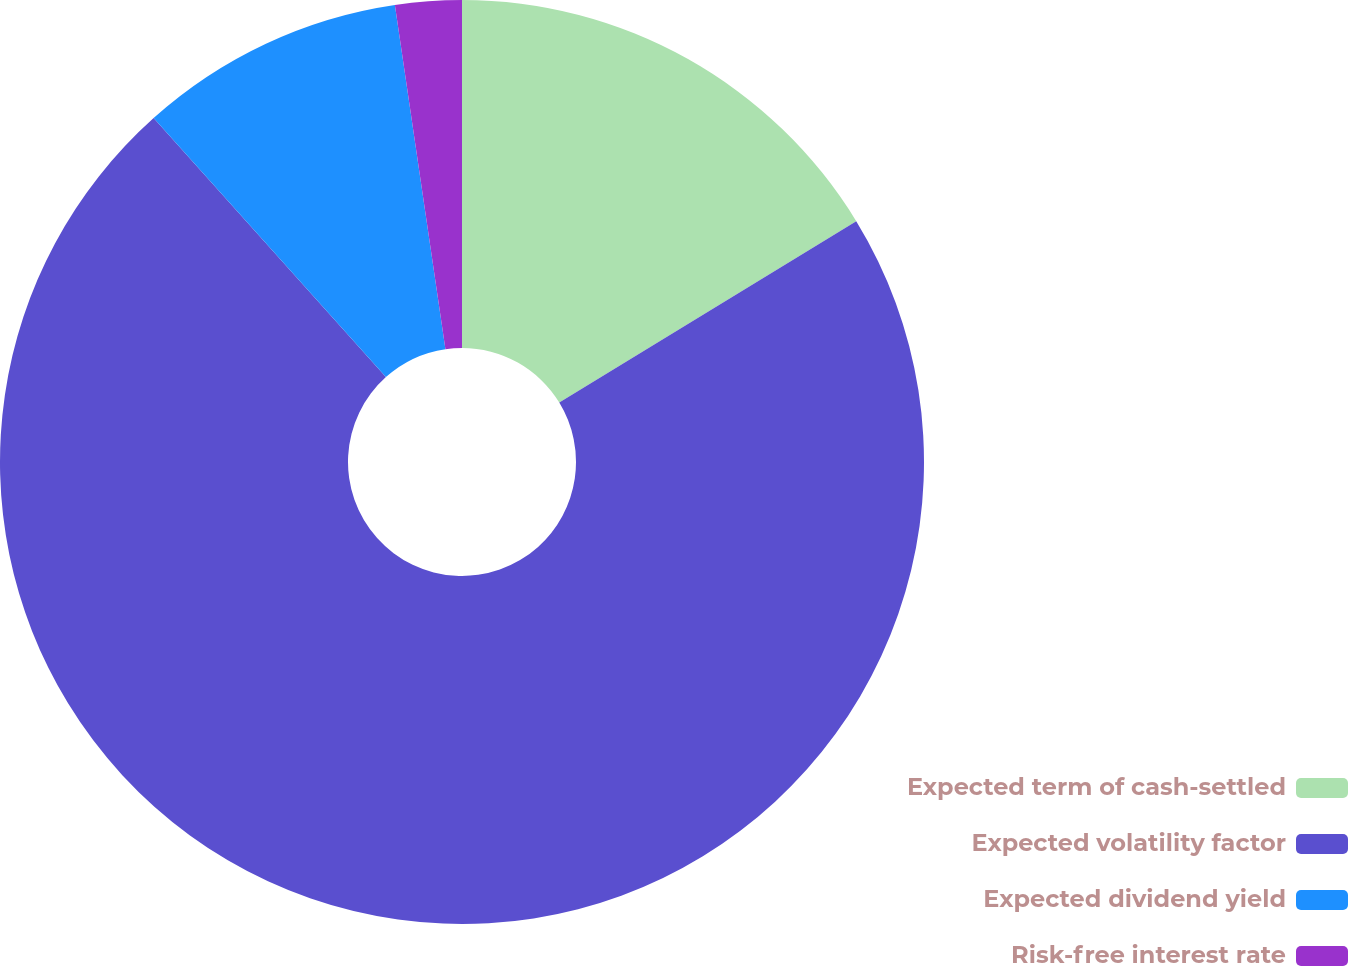Convert chart. <chart><loc_0><loc_0><loc_500><loc_500><pie_chart><fcel>Expected term of cash-settled<fcel>Expected volatility factor<fcel>Expected dividend yield<fcel>Risk-free interest rate<nl><fcel>16.27%<fcel>72.09%<fcel>9.31%<fcel>2.32%<nl></chart> 